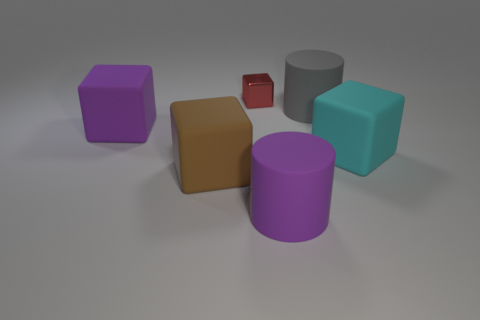There is another tiny object that is the same shape as the brown object; what is its color?
Provide a short and direct response. Red. There is a large matte block on the right side of the red cube; is it the same color as the big matte cylinder behind the purple rubber cube?
Your response must be concise. No. What number of matte things are either red blocks or big purple cylinders?
Your response must be concise. 1. What number of big cubes are right of the big purple object on the right side of the block behind the purple rubber block?
Your answer should be very brief. 1. What size is the cyan cube that is made of the same material as the brown thing?
Give a very brief answer. Large. Does the cube that is in front of the cyan rubber block have the same size as the big purple rubber cylinder?
Give a very brief answer. Yes. What is the color of the big rubber object that is to the left of the big gray rubber cylinder and to the right of the brown block?
Offer a terse response. Purple. How many objects are small red matte things or large matte things in front of the cyan cube?
Make the answer very short. 2. What is the material of the cylinder behind the big rubber cylinder in front of the block that is to the right of the gray cylinder?
Offer a terse response. Rubber. Is there anything else that has the same material as the tiny cube?
Your response must be concise. No. 